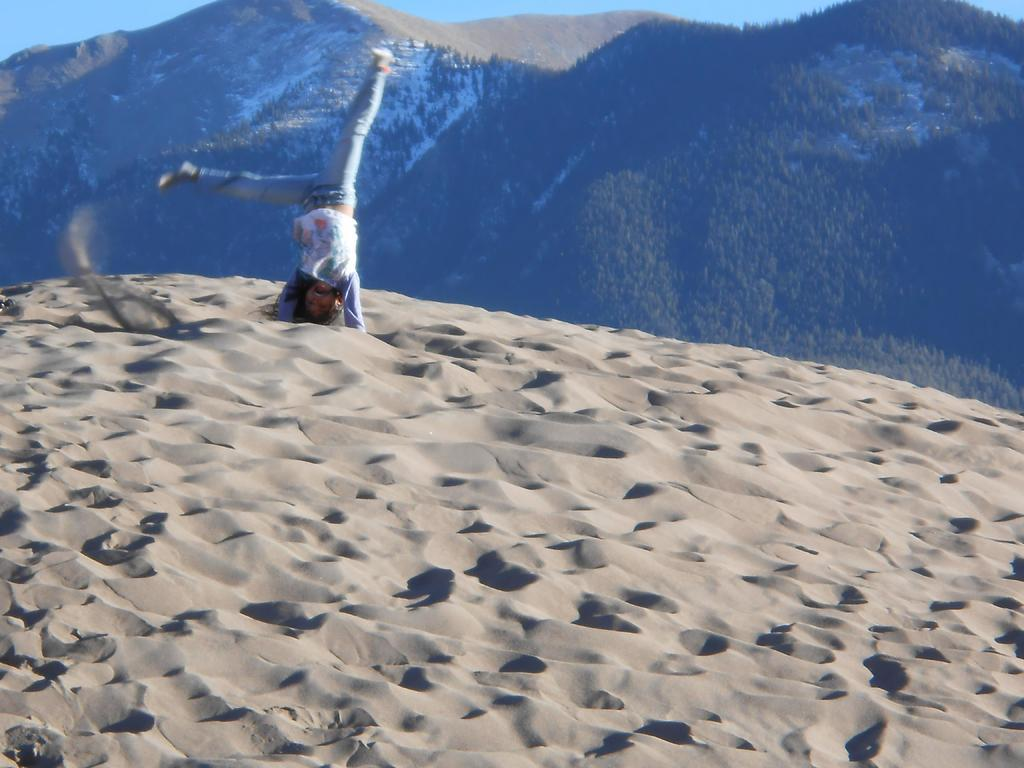Who or what is present in the image? There is a person in the image. What type of terrain is visible at the bottom of the image? There is sand at the bottom of the image. What can be seen in the distance in the image? There are hills in the background of the image. What is visible above the hills in the image? The sky is visible in the background of the image. What historical event is being commemorated by the parcel in the image? There is no parcel present in the image, so it cannot be used to commemorate any historical event. 